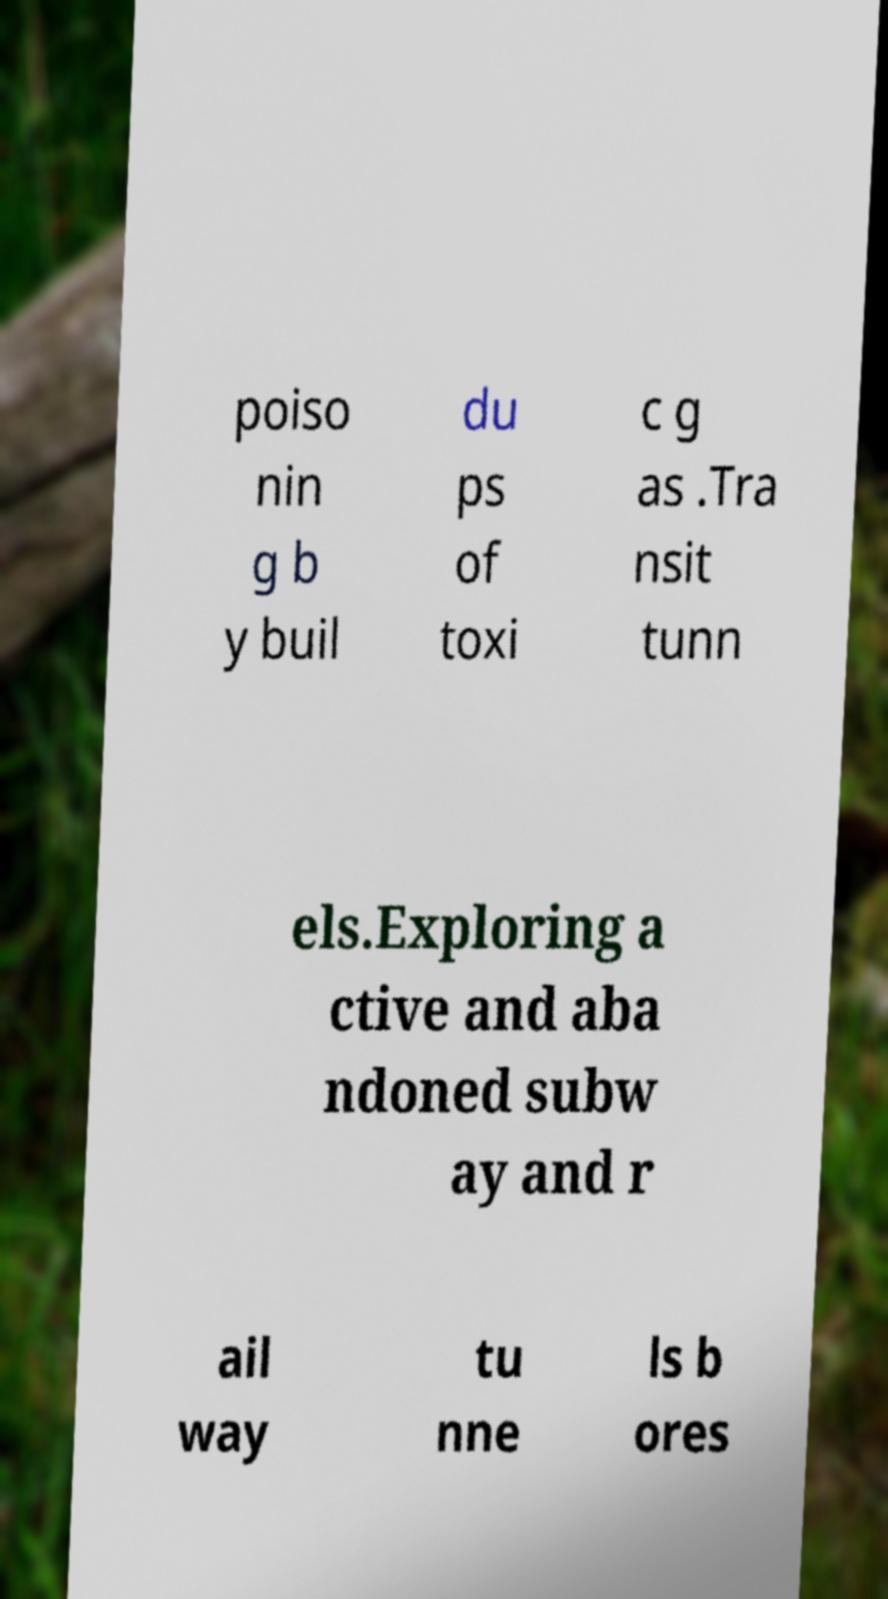Can you read and provide the text displayed in the image?This photo seems to have some interesting text. Can you extract and type it out for me? poiso nin g b y buil du ps of toxi c g as .Tra nsit tunn els.Exploring a ctive and aba ndoned subw ay and r ail way tu nne ls b ores 